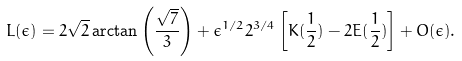<formula> <loc_0><loc_0><loc_500><loc_500>L ( \epsilon ) = 2 \sqrt { 2 } \arctan \left ( \frac { \sqrt { 7 } } { 3 } \right ) + \epsilon ^ { 1 / 2 } 2 ^ { 3 / 4 } \left [ K ( \frac { 1 } { 2 } ) - 2 E ( \frac { 1 } { 2 } ) \right ] + O ( \epsilon ) .</formula> 